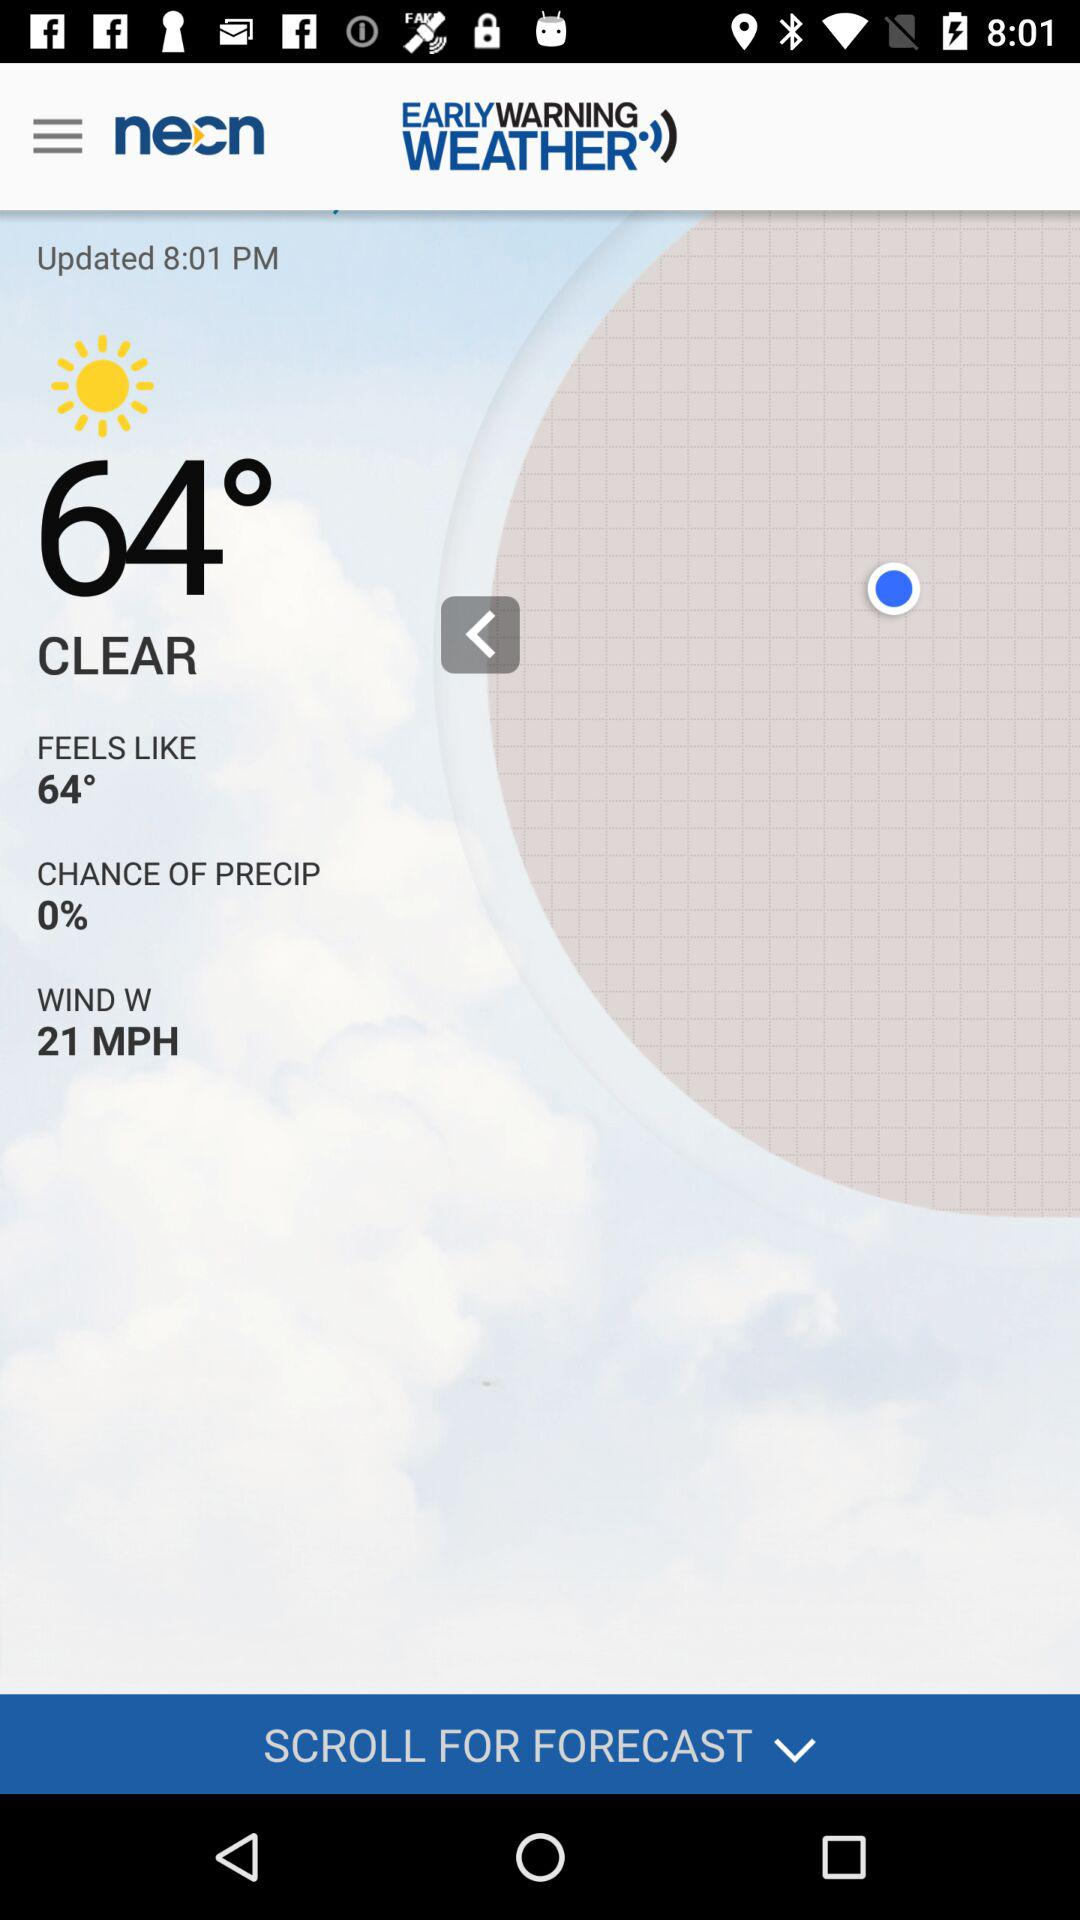What is the wind speed? The wind speed is 21 mph. 